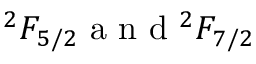<formula> <loc_0><loc_0><loc_500><loc_500>{ } ^ { 2 } F _ { 5 / 2 } a n ^ { 2 } F _ { 7 / 2 }</formula> 